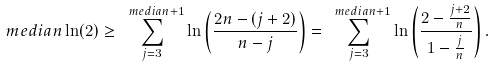Convert formula to latex. <formula><loc_0><loc_0><loc_500><loc_500>\ m e d i a n \ln ( 2 ) \geq \sum _ { j = 3 } ^ { \ m e d i a n + 1 } \ln \left ( \frac { 2 n - ( j + 2 ) } { n - j } \right ) = \sum _ { j = 3 } ^ { \ m e d i a n + 1 } \ln \left ( \frac { 2 - \frac { j + 2 } { n } } { 1 - \frac { j } { n } } \right ) .</formula> 